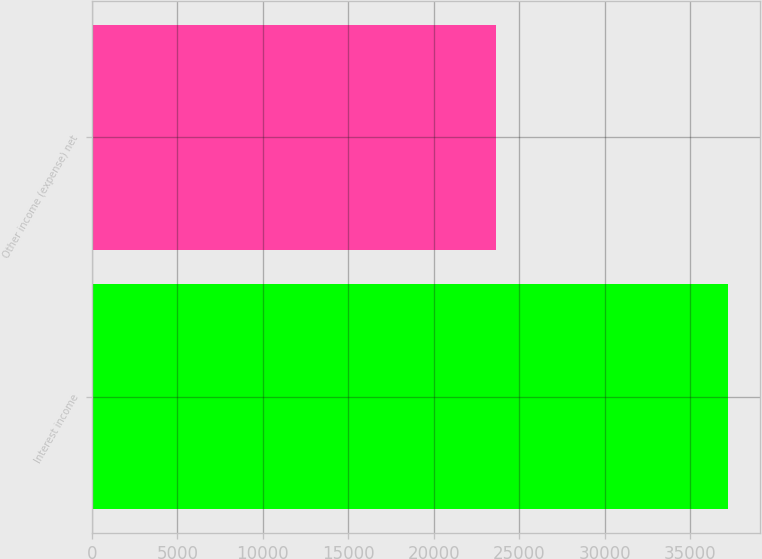Convert chart. <chart><loc_0><loc_0><loc_500><loc_500><bar_chart><fcel>Interest income<fcel>Other income (expense) net<nl><fcel>37210<fcel>23639<nl></chart> 